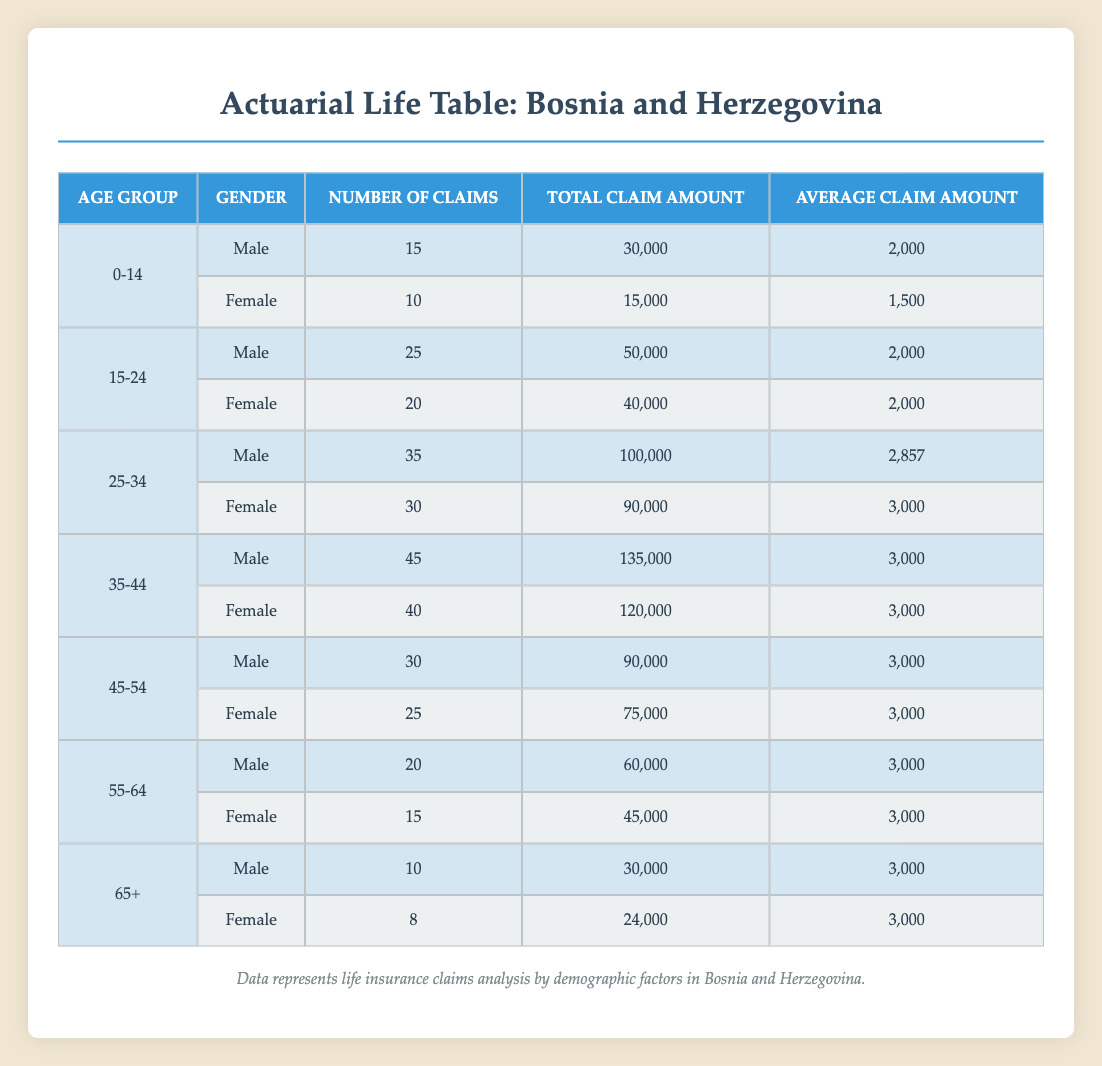What is the total number of claims for females aged 25-34? Looking at the table, the number of claims for females in the 25-34 age group is 30.
Answer: 30 Which age group has the highest total claim amount for males? The total claim amounts for males by age group are: 30,000 (0-14), 50,000 (15-24), 100,000 (25-34), 135,000 (35-44), 90,000 (45-54), 60,000 (55-64), and 30,000 (65+). The highest amount is 135,000 in the 35-44 age group.
Answer: 35-44 Is the average claim amount for females the same across all age groups? The average claim amounts for females by age group are: 1,500 (0-14), 2,000 (15-24), 3,000 (25-34), 3,000 (35-44), 3,000 (45-54), 3,000 (55-64), and 3,000 (65+). The average is not the same, as 0-14 has a lower average of 1,500 compared to the others.
Answer: No What is the total number of claims for males across all age groups? Summing the number of claims for males: 15 (0-14) + 25 (15-24) + 35 (25-34) + 45 (35-44) + 30 (45-54) + 20 (55-64) + 10 (65+) equals 180.
Answer: 180 How does the average claim amount for males aged 25-34 compare to that of females in the same age group? The average claim amount for males in the 25-34 age group is 2,857, while for females in the same group it is 3,000. Therefore, the females have a slightly higher average claim amount.
Answer: Females have a higher average What is the difference in total claim amounts between females aged 15-24 and females aged 45-54? The total claim amount for females aged 15-24 is 40,000 and for 45-54 it is 75,000. The difference is 75,000 - 40,000 = 35,000.
Answer: 35,000 Which gender has a higher total number of claims in the 55-64 age group? In the 55-64 age group, males have 20 claims and females have 15 claims. Thus, males have a higher total number of claims.
Answer: Males How many total claims are there for both genders in the age group 65+? For the 65+ age group, males have 10 claims and females have 8 claims. Adding these together gives 10 + 8 = 18 total claims.
Answer: 18 